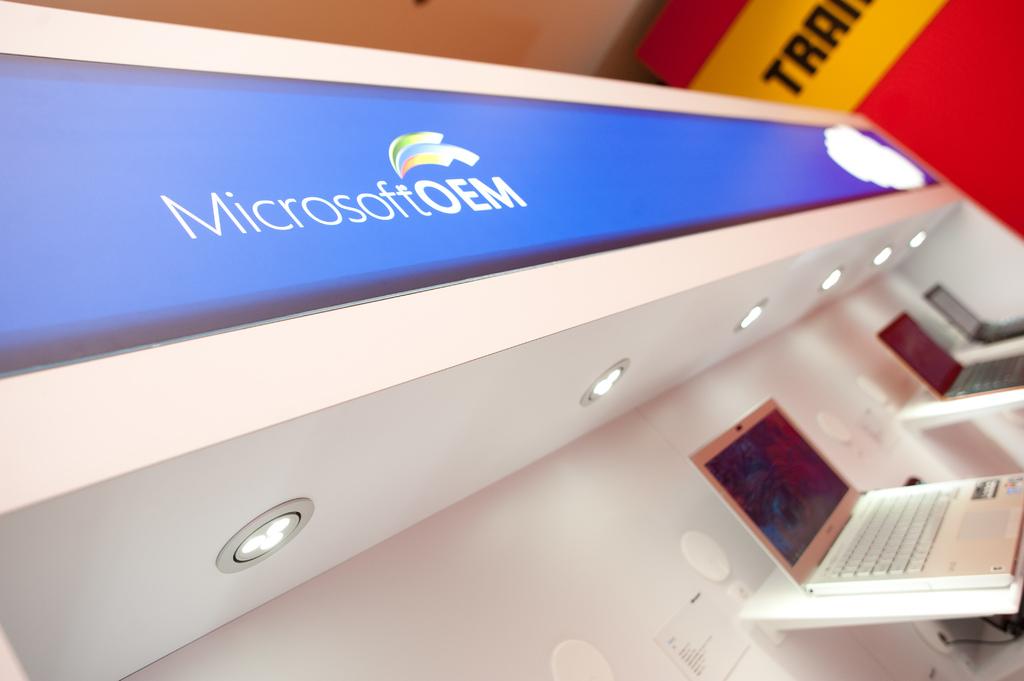What are the three letters shown in yellow on the wall?
Make the answer very short. Tra. 